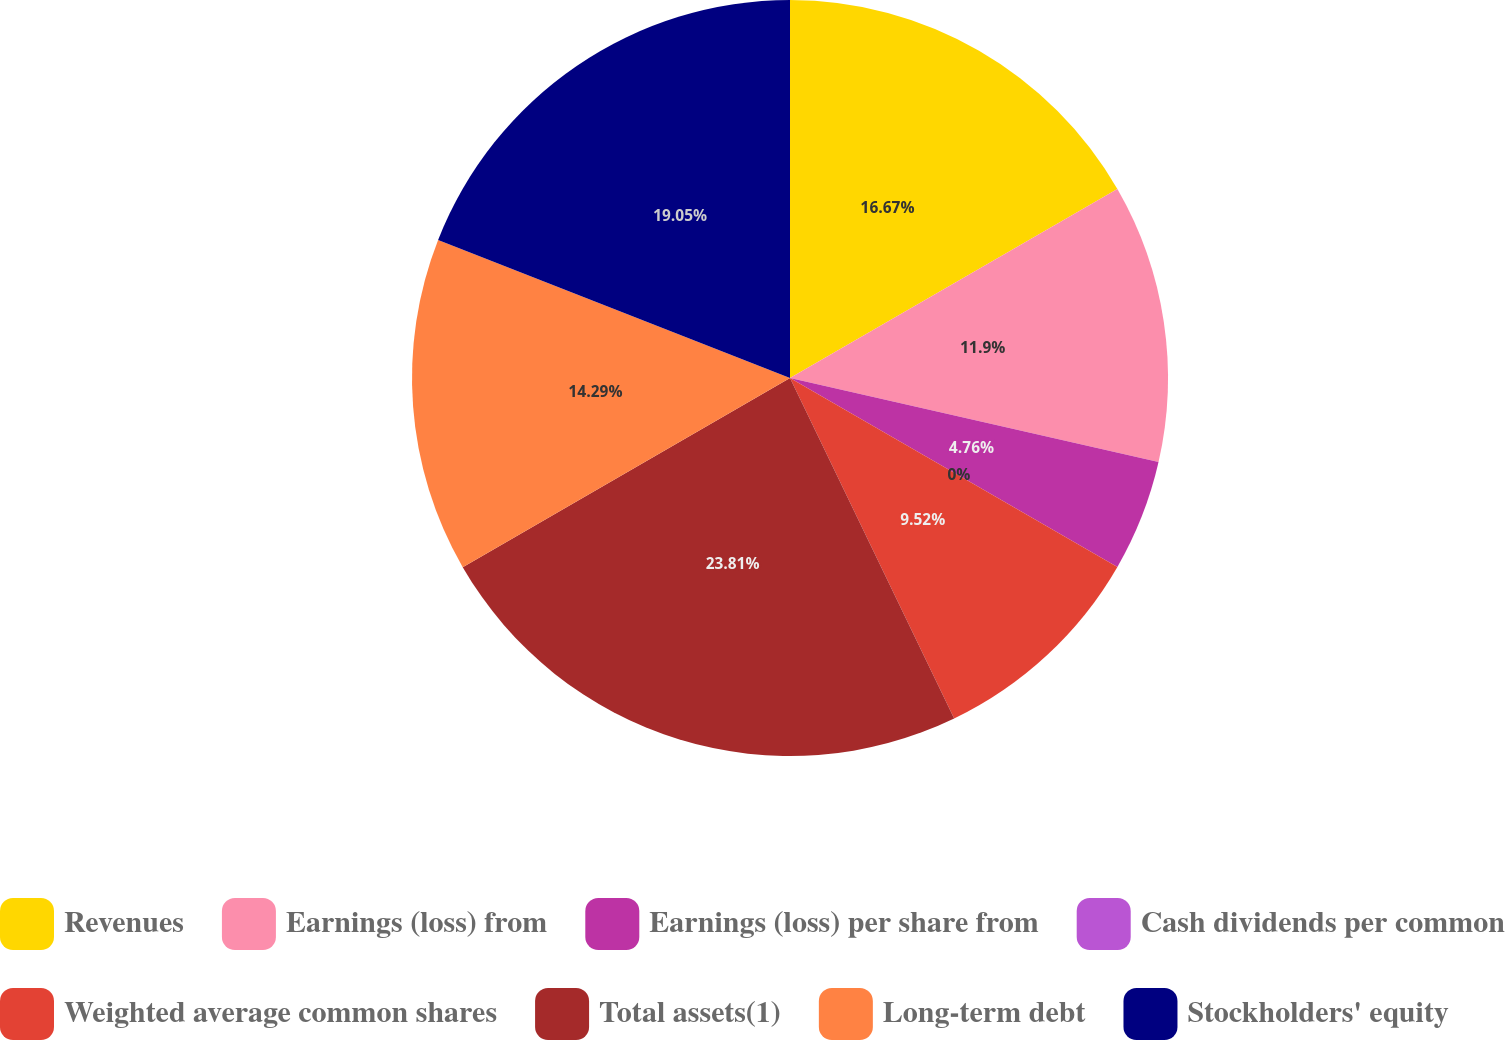Convert chart to OTSL. <chart><loc_0><loc_0><loc_500><loc_500><pie_chart><fcel>Revenues<fcel>Earnings (loss) from<fcel>Earnings (loss) per share from<fcel>Cash dividends per common<fcel>Weighted average common shares<fcel>Total assets(1)<fcel>Long-term debt<fcel>Stockholders' equity<nl><fcel>16.67%<fcel>11.9%<fcel>4.76%<fcel>0.0%<fcel>9.52%<fcel>23.81%<fcel>14.29%<fcel>19.05%<nl></chart> 